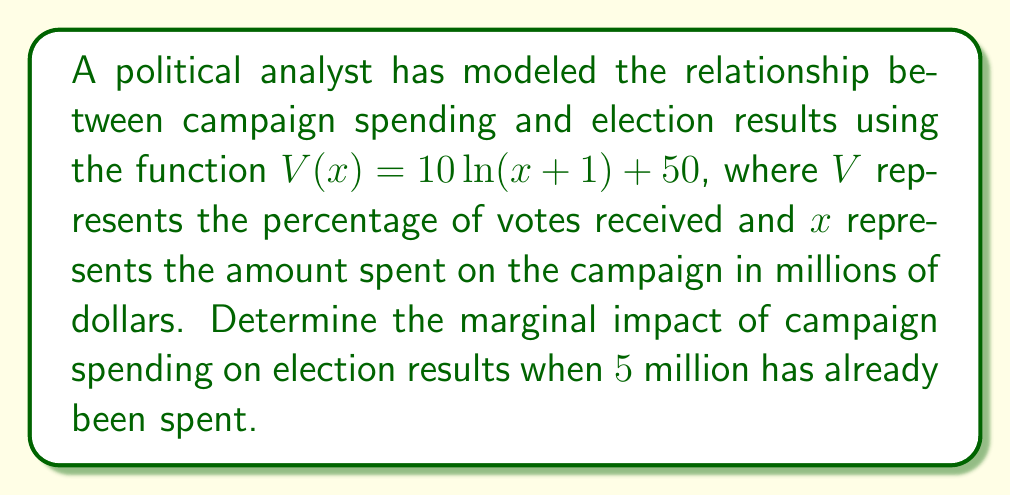Give your solution to this math problem. To find the marginal impact of campaign spending on election results, we need to calculate the derivative of the given function and evaluate it at the specified point.

Step 1: Identify the function
$V(x) = 10\ln(x+1) + 50$

Step 2: Calculate the derivative
Using the chain rule:
$$\frac{dV}{dx} = 10 \cdot \frac{d}{dx}[\ln(x+1)]$$
$$\frac{dV}{dx} = 10 \cdot \frac{1}{x+1}$$

Step 3: Simplify the derivative
$$V'(x) = \frac{10}{x+1}$$

Step 4: Evaluate the derivative at $x = 5$ (since $5 million has already been spent)
$$V'(5) = \frac{10}{5+1} = \frac{10}{6} \approx 1.67$$

This means that when $5 million has been spent, an additional $1 million in campaign spending is expected to increase the vote percentage by approximately 1.67 percentage points.
Answer: $\frac{10}{6}$ or approximately 1.67 percentage points per million dollars 